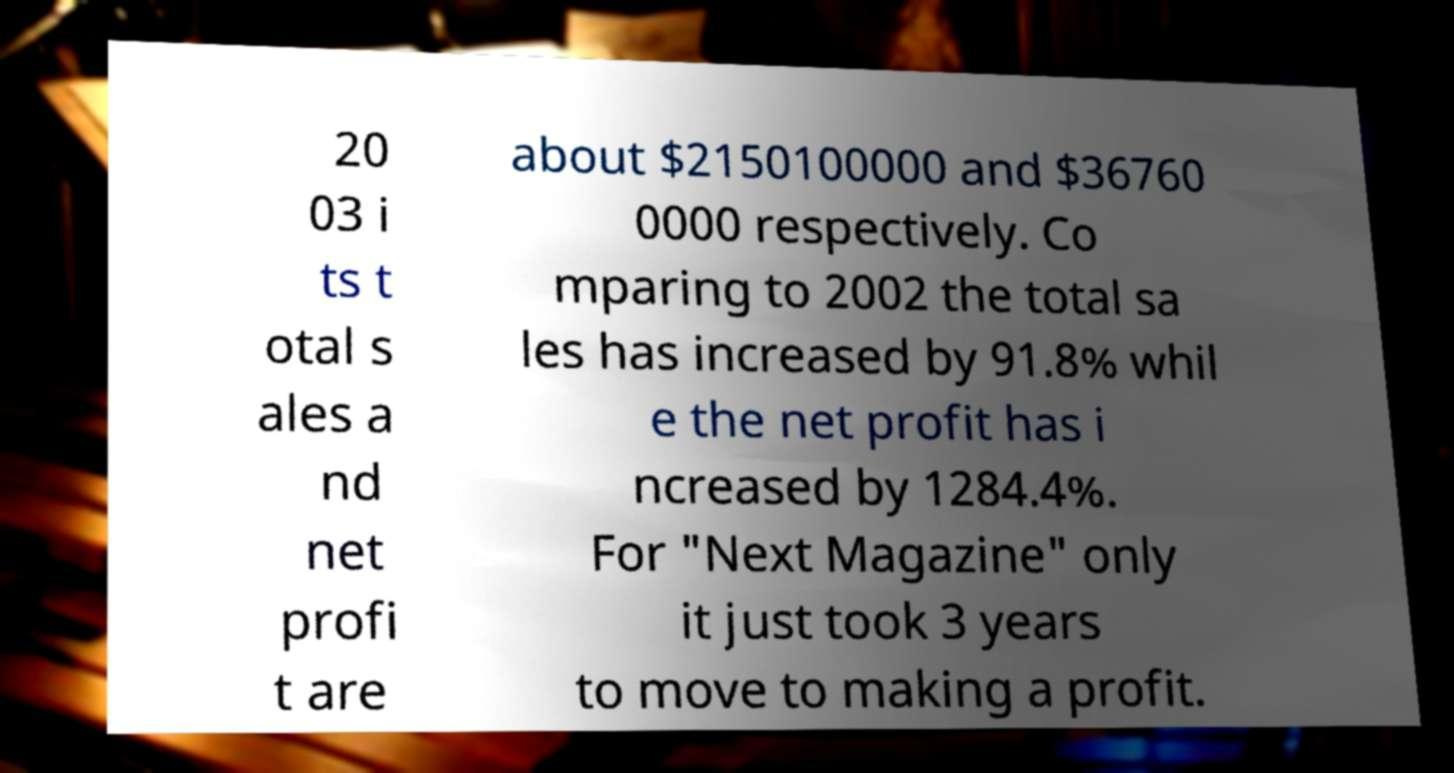Could you extract and type out the text from this image? 20 03 i ts t otal s ales a nd net profi t are about $2150100000 and $36760 0000 respectively. Co mparing to 2002 the total sa les has increased by 91.8% whil e the net profit has i ncreased by 1284.4%. For "Next Magazine" only it just took 3 years to move to making a profit. 